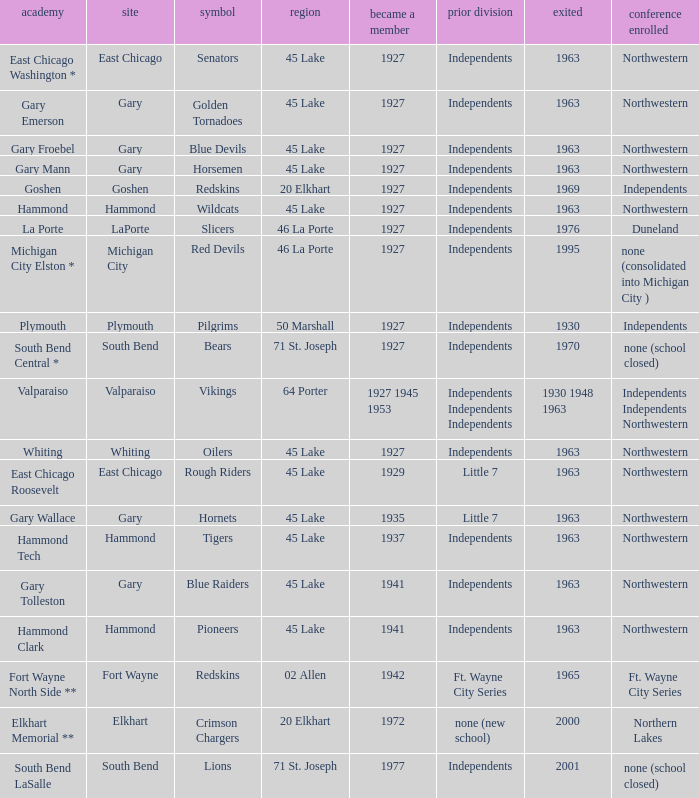Which conference held at School of whiting? Independents. 